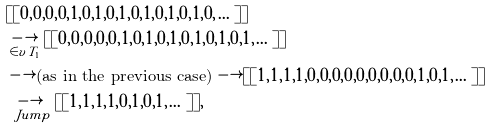Convert formula to latex. <formula><loc_0><loc_0><loc_500><loc_500>& [ [ 0 , 0 , 0 , 0 , 1 , 0 , 1 , 0 , 1 , 0 , 1 , 0 , 1 , 0 , 1 , 0 , \dots ] ] \\ & \underset { \in v { T _ { 1 } } } { \longrightarrow } [ [ 0 , 0 , 0 , 0 , 0 , 1 , 0 , 1 , 0 , 1 , 0 , 1 , 0 , 1 , 0 , 1 , \dots ] ] \\ & \longrightarrow \text {(as in the previous case)} \longrightarrow [ [ 1 , 1 , 1 , 1 , 0 , 0 , 0 , 0 , 0 , 0 , 0 , 0 , 0 , 1 , 0 , 1 , \dots ] ] \\ & \underset { \ J u m p } { \longrightarrow } [ [ 1 , 1 , 1 , 1 , 0 , 1 , 0 , 1 , \dots ] ] ,</formula> 